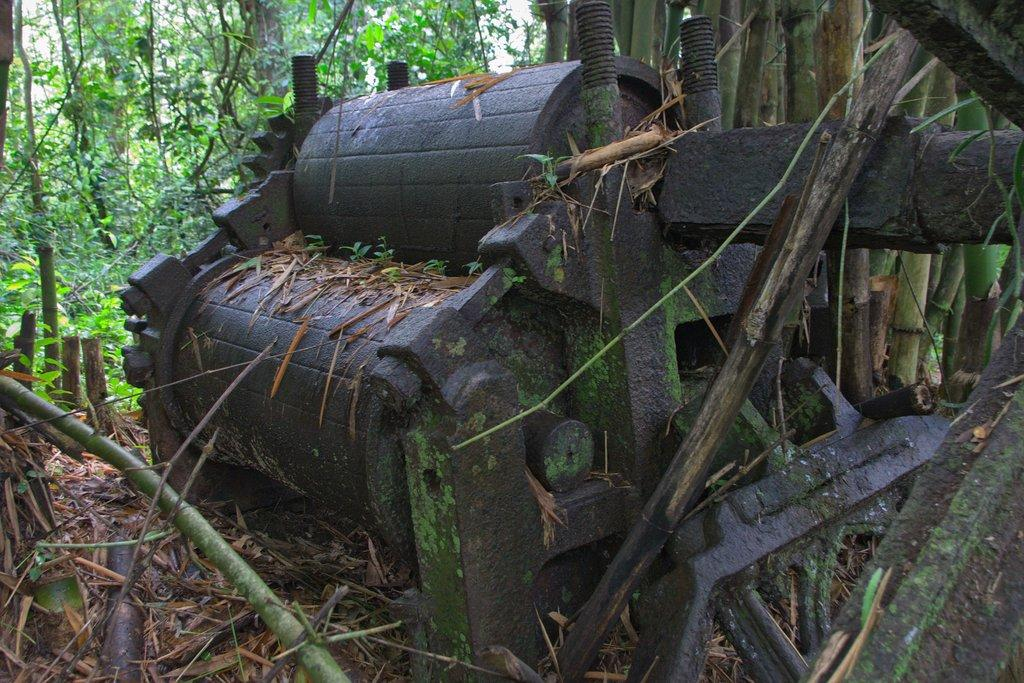What is the main object in the image? There is a machine in the image. What else can be seen in the image besides the machine? There are trees in the image. How many mittens are hanging on the machine in the image? There are no mittens present in the image. What type of lock is securing the trees in the image? There is no lock securing the trees in the image; they are not depicted as being secured. 